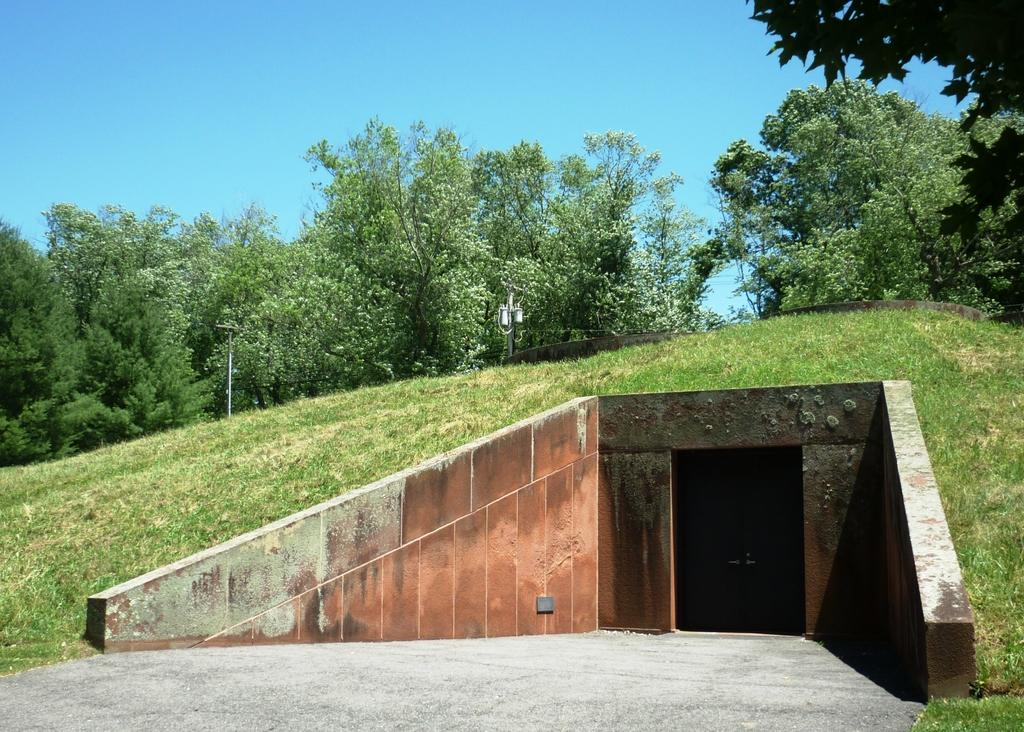What is the main subject of the image? The main subject of the image is a tunnel. What type of vegetation can be seen in the image? There is grass visible in the image. What can be seen in the background of the image? There are trees and the sky visible in the background of the image. What type of sugar is being used by the carpenter in the image? There is no carpenter or sugar present in the image; it features a tunnel with grass, trees, and the sky in the background. 